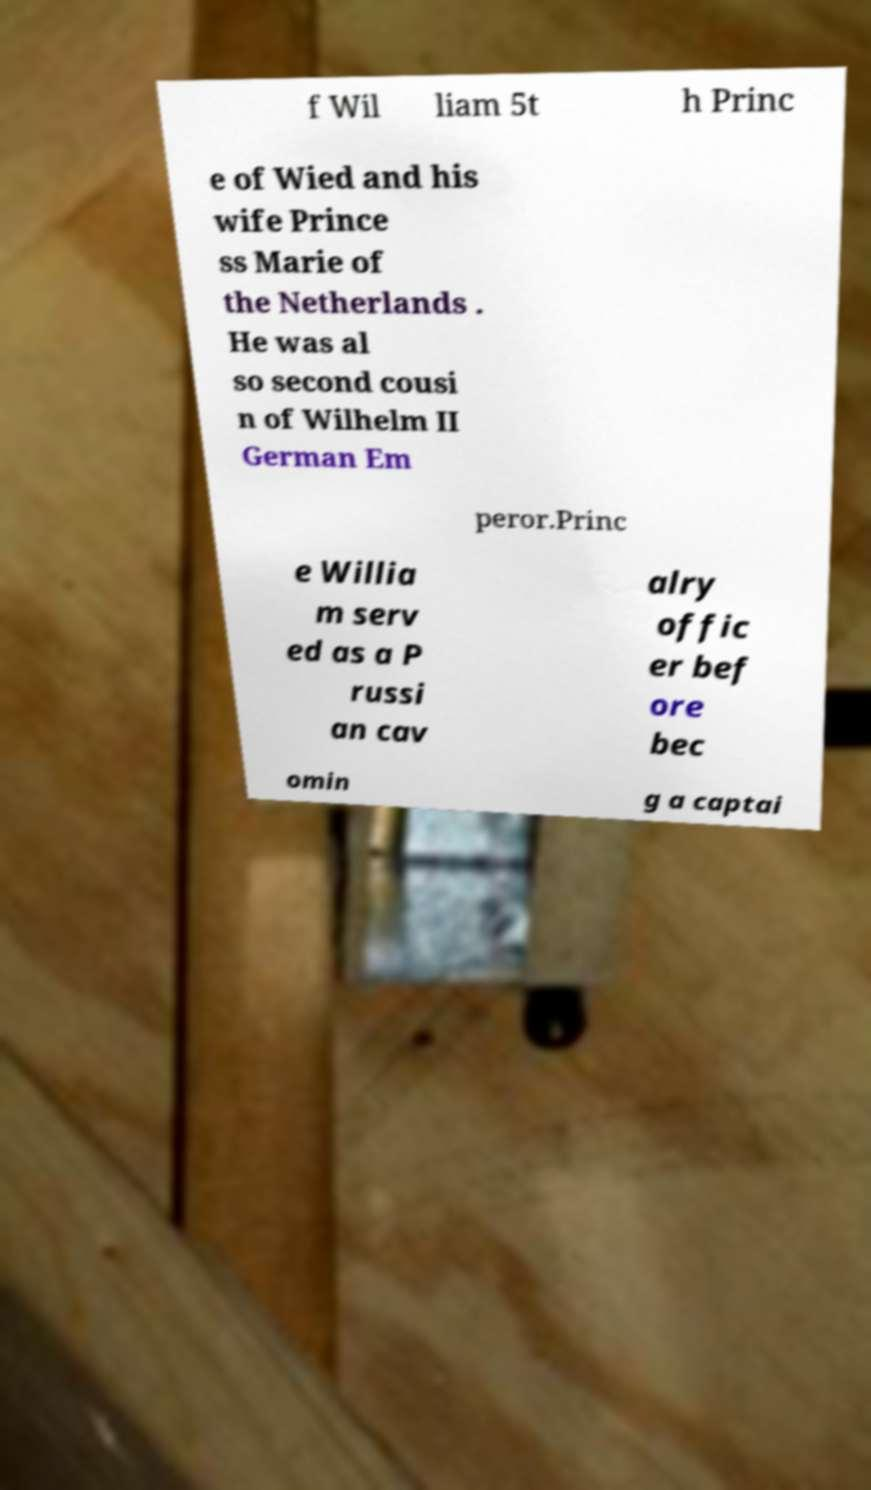I need the written content from this picture converted into text. Can you do that? f Wil liam 5t h Princ e of Wied and his wife Prince ss Marie of the Netherlands . He was al so second cousi n of Wilhelm II German Em peror.Princ e Willia m serv ed as a P russi an cav alry offic er bef ore bec omin g a captai 